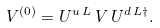Convert formula to latex. <formula><loc_0><loc_0><loc_500><loc_500>V ^ { ( 0 ) } = U ^ { u \, L } \, V \, U ^ { d \, L \dag } .</formula> 